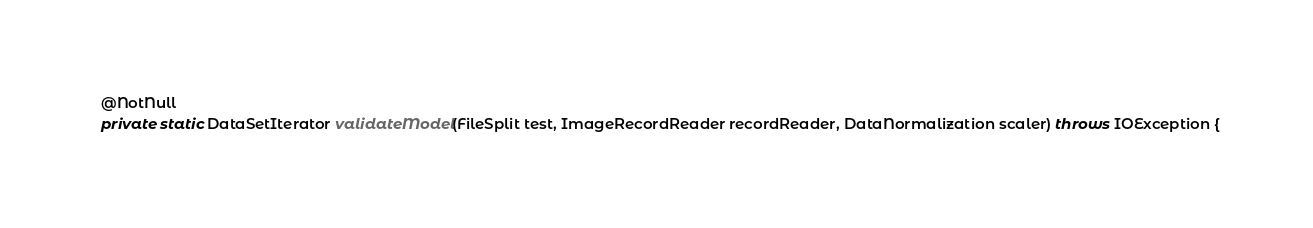Convert code to text. <code><loc_0><loc_0><loc_500><loc_500><_Java_>
  @NotNull
  private static DataSetIterator validateModel(FileSplit test, ImageRecordReader recordReader, DataNormalization scaler) throws IOException {</code> 